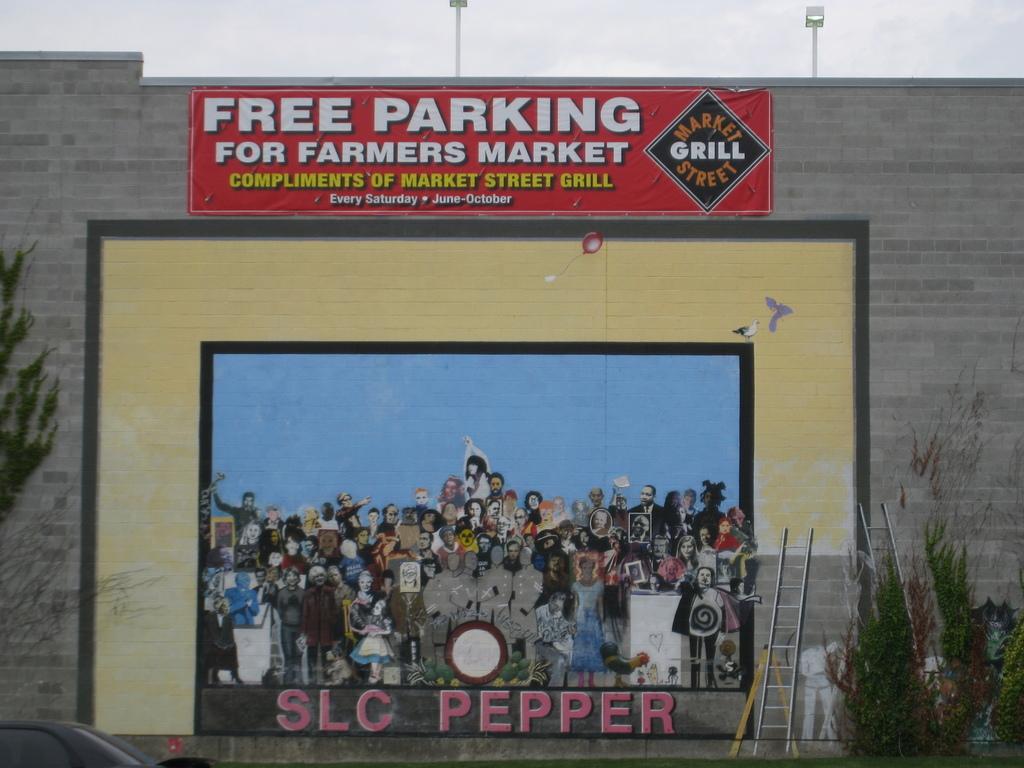Is parking free?
Ensure brevity in your answer.  Yes. 